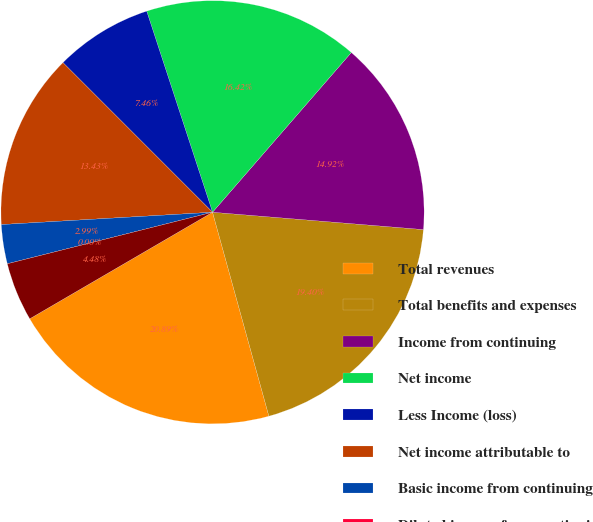Convert chart to OTSL. <chart><loc_0><loc_0><loc_500><loc_500><pie_chart><fcel>Total revenues<fcel>Total benefits and expenses<fcel>Income from continuing<fcel>Net income<fcel>Less Income (loss)<fcel>Net income attributable to<fcel>Basic income from continuing<fcel>Diluted income from continuing<fcel>Basic net income attributable<nl><fcel>20.89%<fcel>19.4%<fcel>14.92%<fcel>16.42%<fcel>7.46%<fcel>13.43%<fcel>2.99%<fcel>0.0%<fcel>4.48%<nl></chart> 